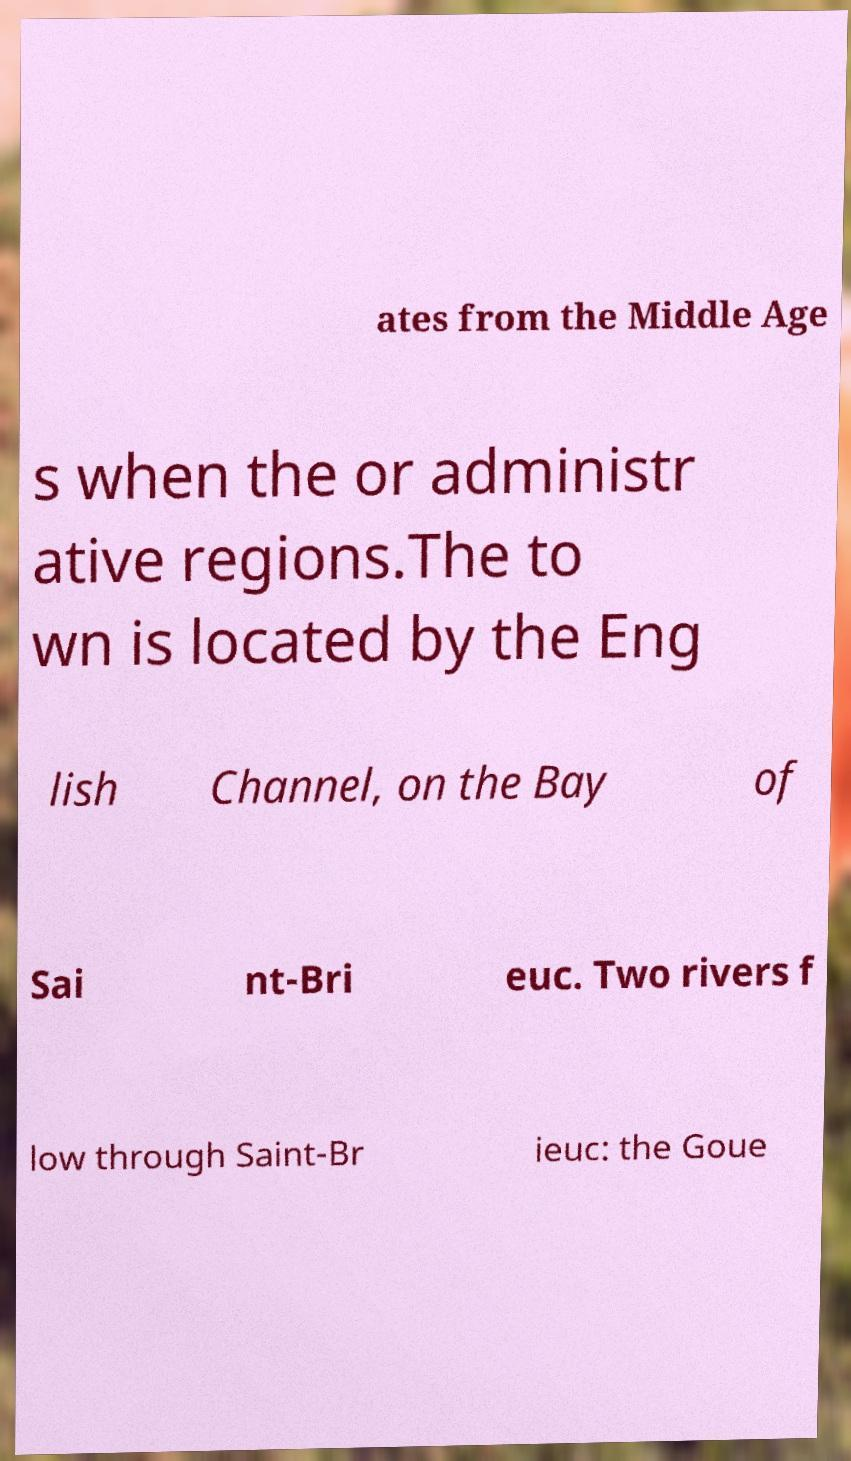What messages or text are displayed in this image? I need them in a readable, typed format. ates from the Middle Age s when the or administr ative regions.The to wn is located by the Eng lish Channel, on the Bay of Sai nt-Bri euc. Two rivers f low through Saint-Br ieuc: the Goue 